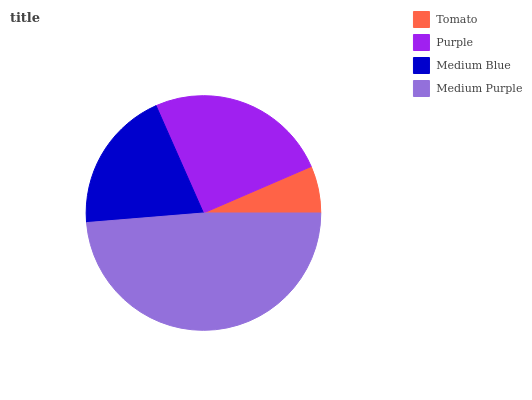Is Tomato the minimum?
Answer yes or no. Yes. Is Medium Purple the maximum?
Answer yes or no. Yes. Is Purple the minimum?
Answer yes or no. No. Is Purple the maximum?
Answer yes or no. No. Is Purple greater than Tomato?
Answer yes or no. Yes. Is Tomato less than Purple?
Answer yes or no. Yes. Is Tomato greater than Purple?
Answer yes or no. No. Is Purple less than Tomato?
Answer yes or no. No. Is Purple the high median?
Answer yes or no. Yes. Is Medium Blue the low median?
Answer yes or no. Yes. Is Tomato the high median?
Answer yes or no. No. Is Medium Purple the low median?
Answer yes or no. No. 